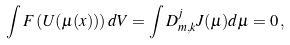Convert formula to latex. <formula><loc_0><loc_0><loc_500><loc_500>\int F \left ( U ( \mu ( x ) ) \right ) d V = \int D _ { m , k } ^ { j } J ( \mu ) d \mu = 0 \, ,</formula> 